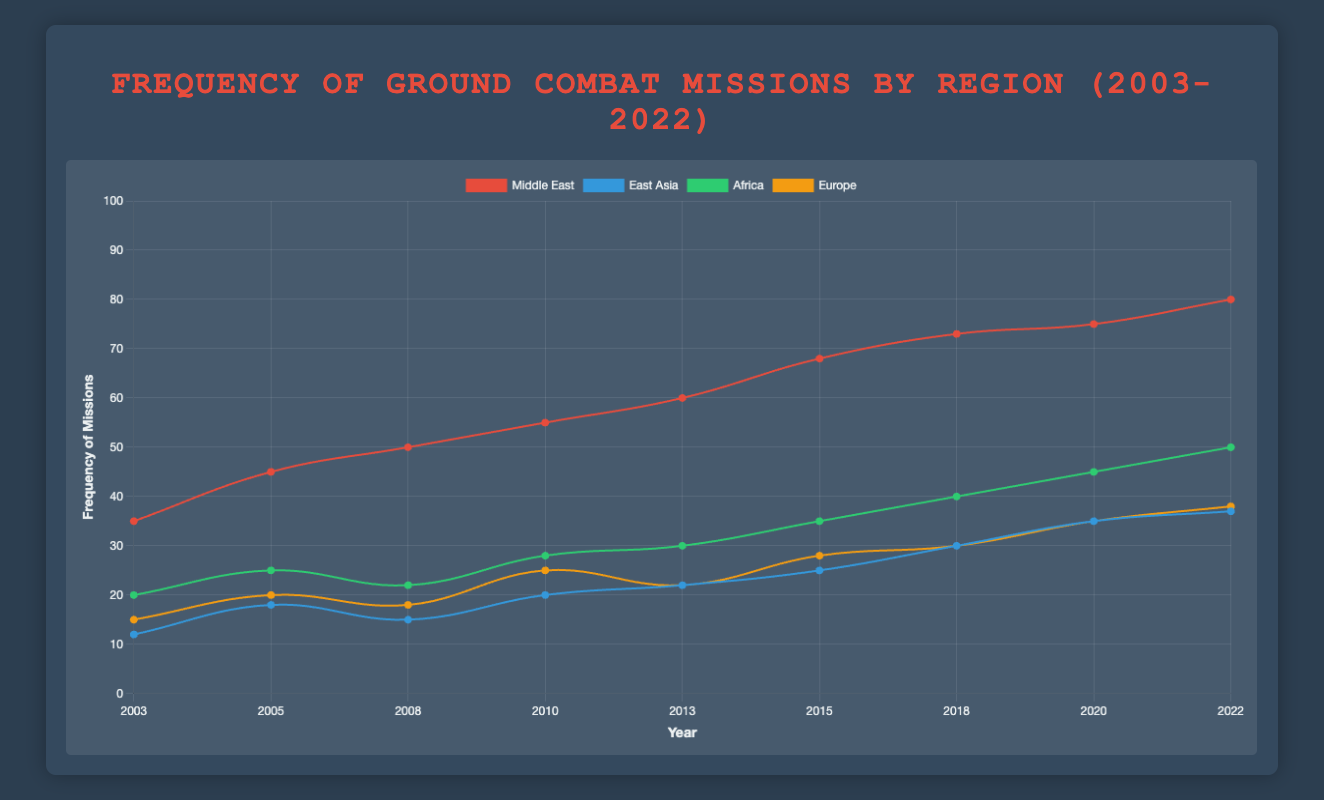Which region had the highest frequency of missions in 2005? Looking at the year 2005, the "Middle East" had the highest frequency with 45 missions.
Answer: Middle East By how much did the frequency of ground combat missions in East Asia increase from 2003 to 2022? The frequency of East Asia increased from 12 in 2003 to 37 in 2022, the increase is calculated as 37 - 12.
Answer: 25 Which two regions had equal frequencies of ground combat missions in the year 2020? Observing the data for the year 2020, both Africa and Europe had equal frequencies of 35 missions.
Answer: Africa and Europe What is the total frequency of missions for the Middle East and Africa in 2015? Summing the frequencies for the Middle East and Africa in 2015, 68 + 35 results in a total frequency of 103 missions.
Answer: 103 In which year did Europe see the greatest increase in mission frequency compared to the previous recorded year, and what was the increase? Comparing each year to the previous one for Europe:
* 2003 to 2005: increase of 20 - 15 = 5
* 2005 to 2008: decrease of 18 - 20 = -2
* 2008 to 2010: increase of 25 - 18 = 7
* 2010 to 2013: decrease of 22 - 25 = -3
* 2013 to 2015: increase of 28 - 22 = 6
* 2015 to 2018: increase of 30 - 28 = 2
* 2018 to 2020: increase of 35 - 30 = 5
The greatest increase is from 2008 to 2010 with an increase of 7.
Answer: 2010, 7 Which region showed the most consistent increase in mission frequency over the years? Observing each region over the years:
* Middle East increased steadily from 2003 to 2022.
* East Asia showed some fluctuations.
* Africa also increased but with some larger steps.
* Europe showed both increases and decreases.
The Middle East had the most consistent increase.
Answer: Middle East What is the difference in mission frequency between the highest and lowest regions in 2022? In the year 2022, Middle East had the highest frequency of 80 and Europe had the lowest of 38. The difference is 80 - 38.
Answer: 42 Which year saw the smallest frequency of missions in East Asia within the given period? The lowest frequency for East Asia occurs in 2003 with a frequency of 12.
Answer: 2003 